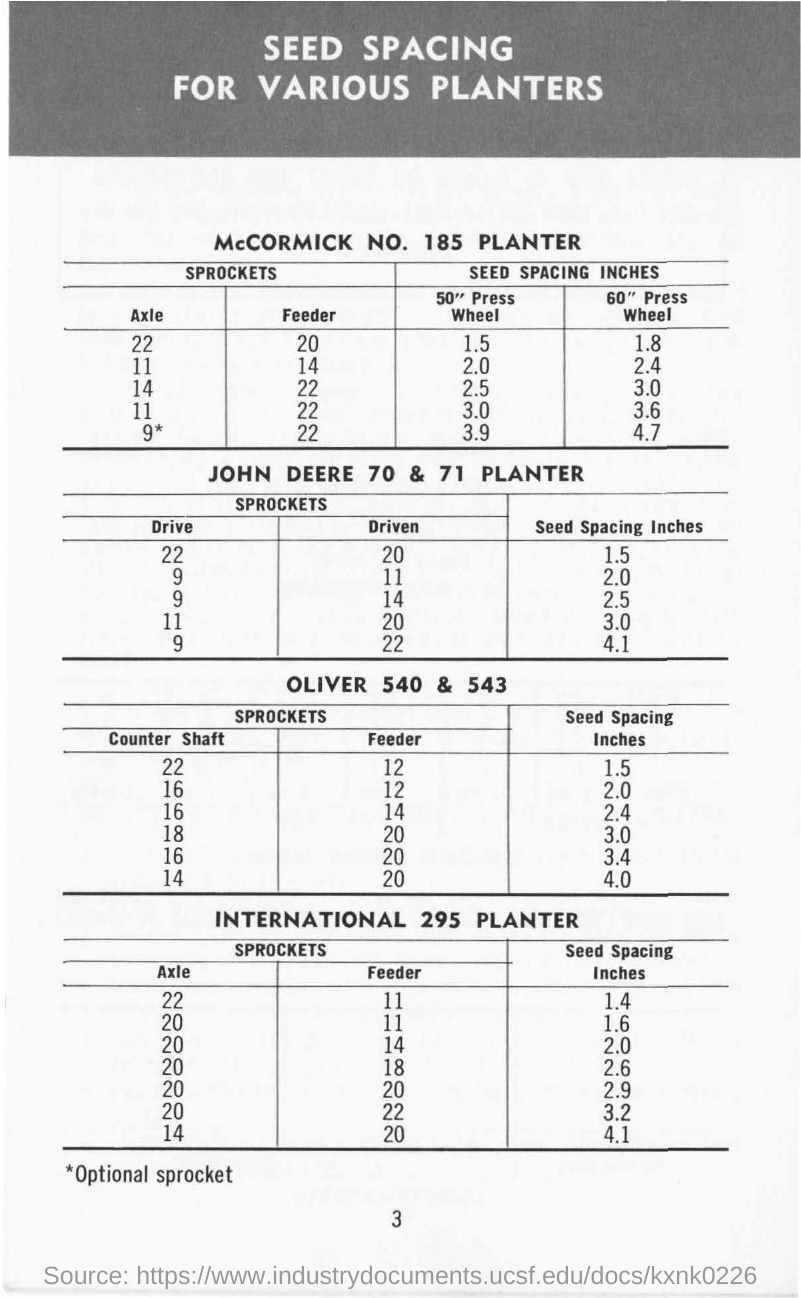Draw attention to some important aspects in this diagram. The document's title is "Seed Spacing for Various Planters. 